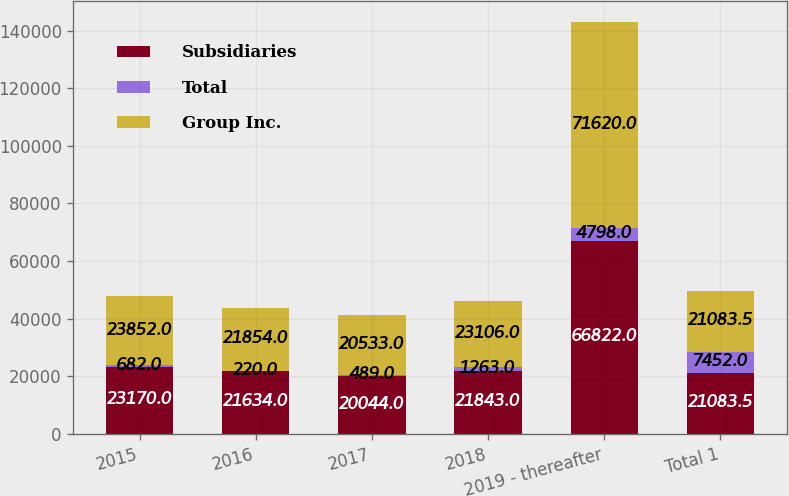<chart> <loc_0><loc_0><loc_500><loc_500><stacked_bar_chart><ecel><fcel>2015<fcel>2016<fcel>2017<fcel>2018<fcel>2019 - thereafter<fcel>Total 1<nl><fcel>Subsidiaries<fcel>23170<fcel>21634<fcel>20044<fcel>21843<fcel>66822<fcel>21083.5<nl><fcel>Total<fcel>682<fcel>220<fcel>489<fcel>1263<fcel>4798<fcel>7452<nl><fcel>Group Inc.<fcel>23852<fcel>21854<fcel>20533<fcel>23106<fcel>71620<fcel>21083.5<nl></chart> 